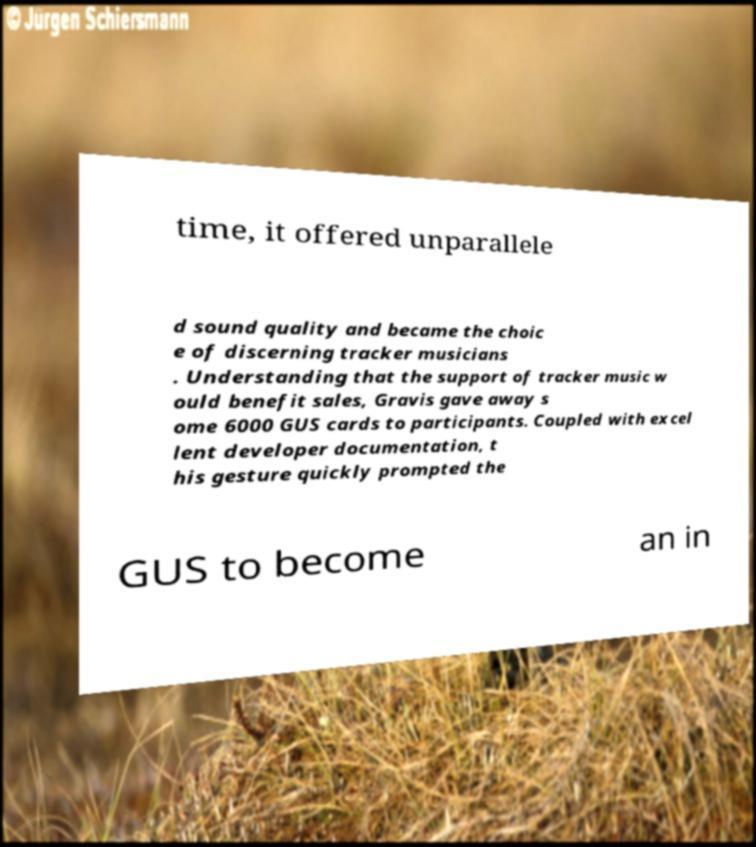Please identify and transcribe the text found in this image. time, it offered unparallele d sound quality and became the choic e of discerning tracker musicians . Understanding that the support of tracker music w ould benefit sales, Gravis gave away s ome 6000 GUS cards to participants. Coupled with excel lent developer documentation, t his gesture quickly prompted the GUS to become an in 